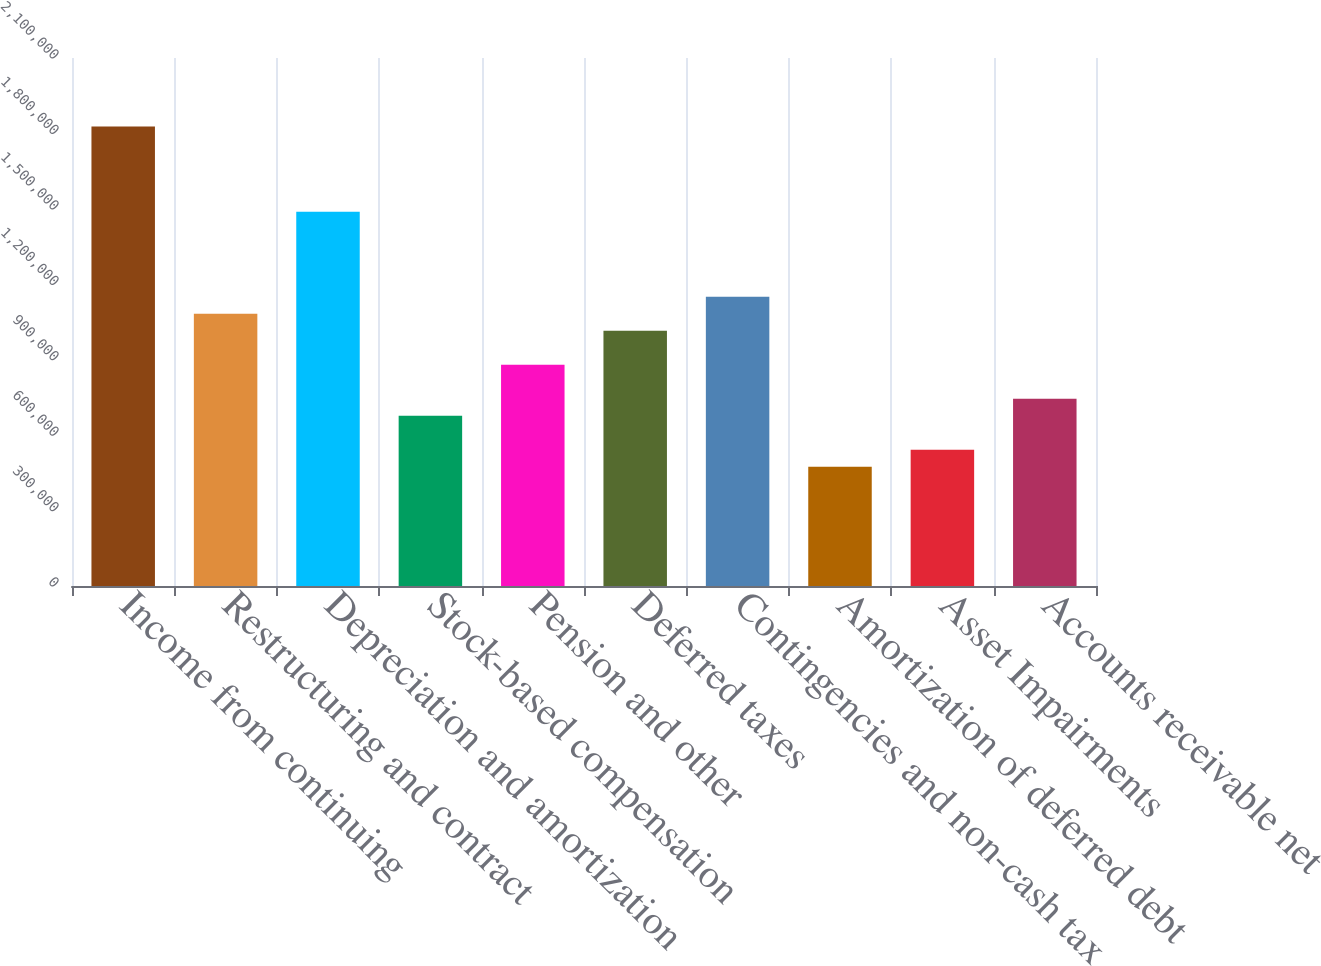<chart> <loc_0><loc_0><loc_500><loc_500><bar_chart><fcel>Income from continuing<fcel>Restructuring and contract<fcel>Depreciation and amortization<fcel>Stock-based compensation<fcel>Pension and other<fcel>Deferred taxes<fcel>Contingencies and non-cash tax<fcel>Amortization of deferred debt<fcel>Asset Impairments<fcel>Accounts receivable net<nl><fcel>1.82706e+06<fcel>1.0829e+06<fcel>1.48881e+06<fcel>677000<fcel>879952<fcel>1.01525e+06<fcel>1.15055e+06<fcel>474048<fcel>541699<fcel>744651<nl></chart> 